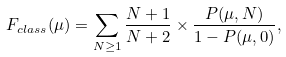<formula> <loc_0><loc_0><loc_500><loc_500>F _ { c l a s s } ( \mu ) = \sum _ { N \geq 1 } \frac { N + 1 } { N + 2 } \times \frac { P ( \mu , N ) } { 1 - P ( \mu , 0 ) } ,</formula> 